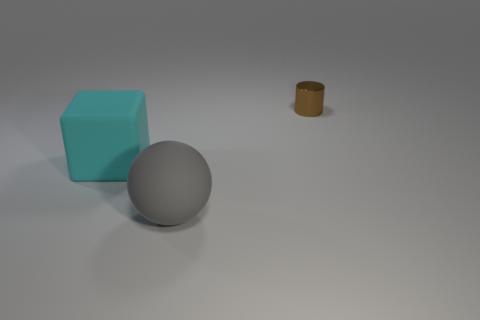Is there a big rubber block?
Provide a short and direct response. Yes. Is there a large green sphere made of the same material as the gray object?
Make the answer very short. No. Is there anything else that has the same material as the small brown object?
Your answer should be very brief. No. The small metal object has what color?
Offer a terse response. Brown. There is a cube that is the same size as the gray thing; what is its color?
Provide a short and direct response. Cyan. What number of matte objects are either cylinders or big cyan cylinders?
Ensure brevity in your answer.  0. What number of things are both right of the large cyan matte block and on the left side of the cylinder?
Your answer should be very brief. 1. Are there any other things that are the same shape as the cyan thing?
Your answer should be compact. No. How many other things are the same size as the cyan rubber cube?
Provide a short and direct response. 1. Do the object that is right of the gray object and the rubber thing that is in front of the matte block have the same size?
Your response must be concise. No. 